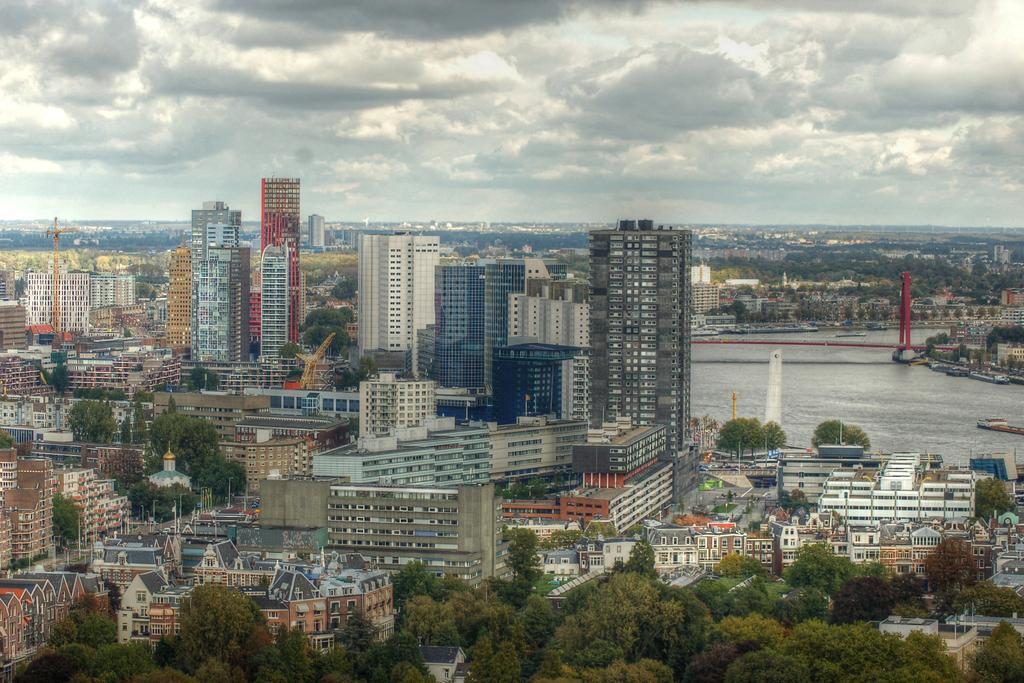What type of structures can be seen in the image? There are many buildings in the image. What natural elements are present in the image? There are trees and a river in the image. What man-made structure connects the two sides of the river? There is a bridge in the image. What type of vehicle is present in the image? There is a boat in the image. What can be seen in the background of the image? The sky is visible in the background of the image. What type of chain can be seen hanging from the bridge in the image? There is no chain hanging from the bridge in the image. What angle does the boat make with the river in the image? The angle of the boat in relation to the river cannot be determined from the image. 